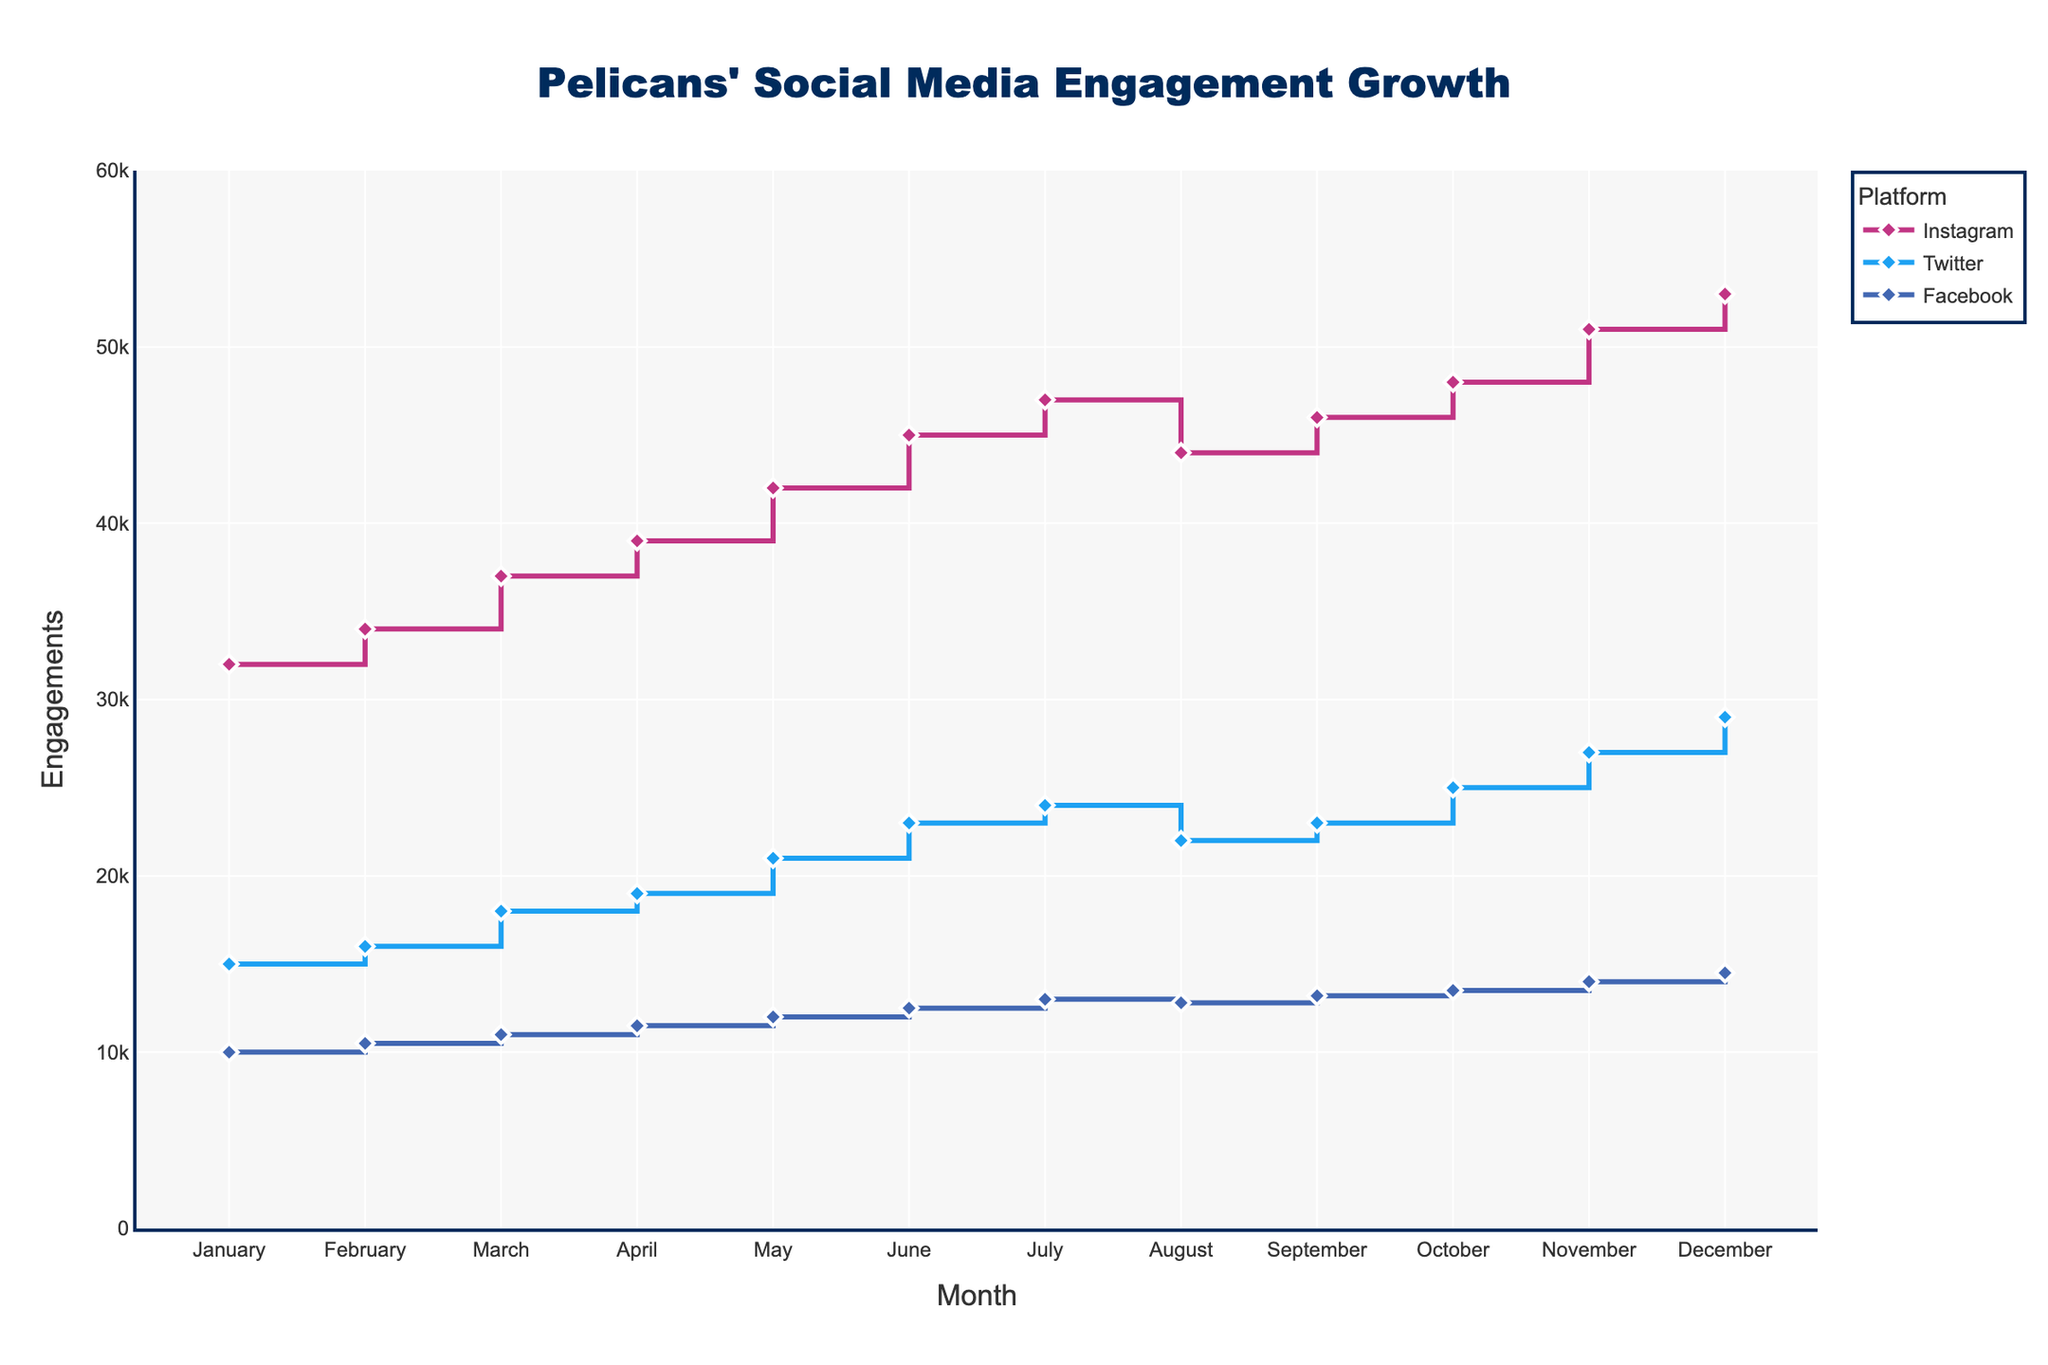What is the title of the figure? The title is located at the top center of the figure and is clearly marked.
Answer: Pelicans' Social Media Engagement Growth How many months are displayed on the x-axis? The x-axis represents months and shows 12 data points depicting each month of the year.
Answer: 12 Which platform had the highest engagements in December? Look at the engagement values for each platform in December. Instagram's value is the highest at 53,000.
Answer: Instagram What is the difference in engagements between January and December for Twitter? Subtract January's Twitter engagements from December's Twitter engagements: 29,000 - 15,000 = 14,000.
Answer: 14,000 Which platform showed the most significant drop in engagement in August? Compare the drop in engagements from July to August for all platforms. Instagram dropped from 47,000 to 44,000, the most substantial drop.
Answer: Instagram In which month did Facebook have exactly 14,000 engagements? Look for the month on the x-axis where Facebook's engagement line touches 14,000 on the y-axis.
Answer: November How much did Instagram engagements increase from January to June? Subtract the January value from the June value for Instagram: 45,000 - 32,000 = 13,000.
Answer: 13,000 Compare the growth patterns of Twitter and Facebook. Which platform had more consistent growth? Twitter's engagements increased steadily every month whereas Facebook had minor fluctuations in August.
Answer: Twitter What is the color used to represent Twitter in the figure? By observing the color legend or lines, Twitter is depicted in light blue.
Answer: Light blue What is the average engagement for Instagram over the year? Sum all monthly engagements for Instagram and divide by 12: (32000 + 34000 + 37000 + 39000 + 42000 + 45000 + 47000 + 44000 + 46000 + 48000 + 51000 + 53000) / 12 = 42833.33.
Answer: 42833.33 